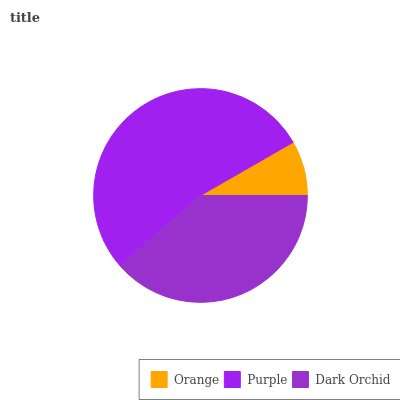Is Orange the minimum?
Answer yes or no. Yes. Is Purple the maximum?
Answer yes or no. Yes. Is Dark Orchid the minimum?
Answer yes or no. No. Is Dark Orchid the maximum?
Answer yes or no. No. Is Purple greater than Dark Orchid?
Answer yes or no. Yes. Is Dark Orchid less than Purple?
Answer yes or no. Yes. Is Dark Orchid greater than Purple?
Answer yes or no. No. Is Purple less than Dark Orchid?
Answer yes or no. No. Is Dark Orchid the high median?
Answer yes or no. Yes. Is Dark Orchid the low median?
Answer yes or no. Yes. Is Purple the high median?
Answer yes or no. No. Is Purple the low median?
Answer yes or no. No. 